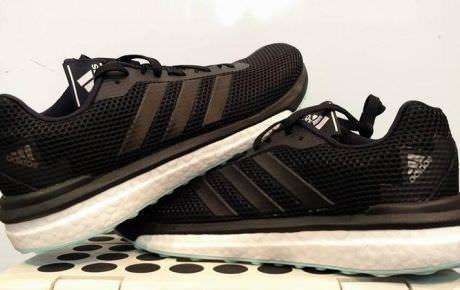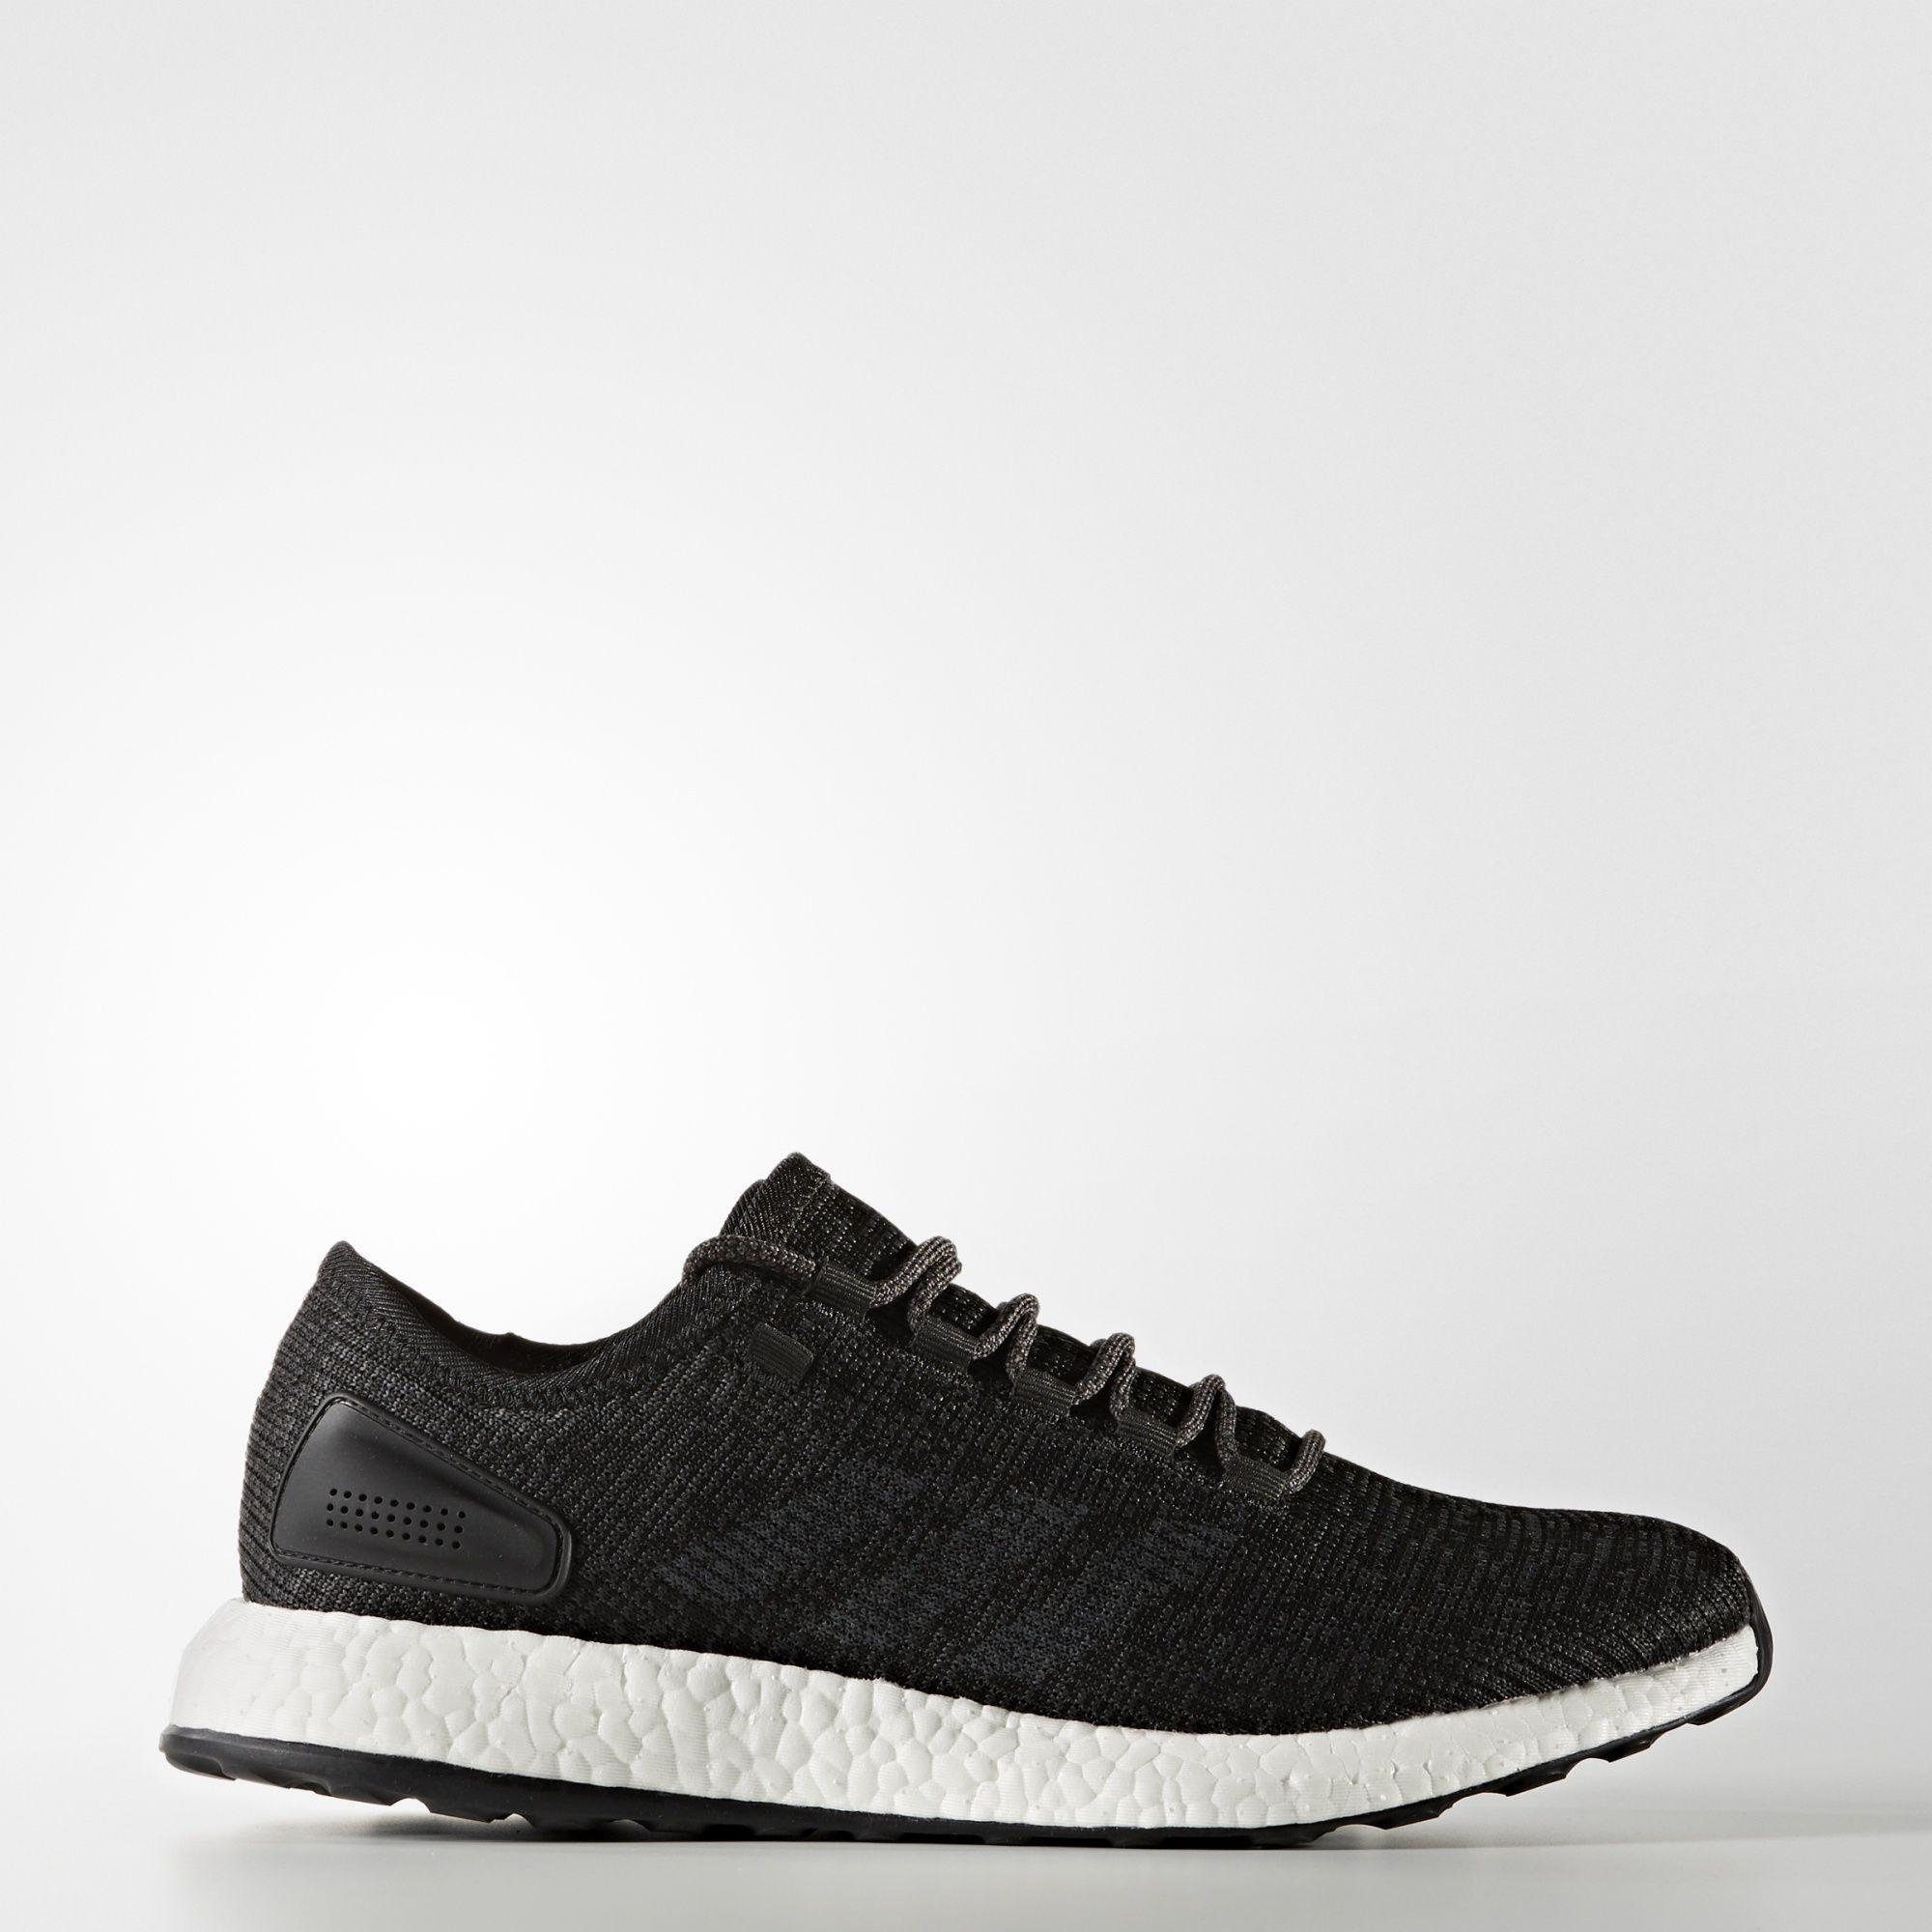The first image is the image on the left, the second image is the image on the right. Examine the images to the left and right. Is the description "At least one image has more than one sneaker in it." accurate? Answer yes or no. Yes. 